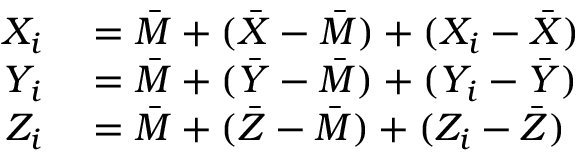<formula> <loc_0><loc_0><loc_500><loc_500>\begin{array} { r l } { X _ { i } } & = { \bar { M } } + ( { \bar { X } } - { \bar { M } } ) + ( X _ { i } - { \bar { X } } ) } \\ { Y _ { i } } & = { \bar { M } } + ( { \bar { Y } } - { \bar { M } } ) + ( Y _ { i } - { \bar { Y } } ) } \\ { Z _ { i } } & = { \bar { M } } + ( { \bar { Z } } - { \bar { M } } ) + ( Z _ { i } - { \bar { Z } } ) } \end{array}</formula> 